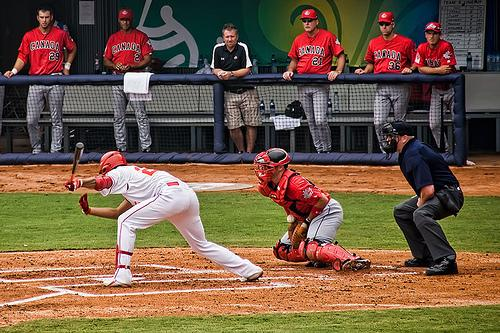What is the main object being used by the player in the image, and what is he doing with it? The main object used is a baseball bat, and the player is swinging it. Describe what the spectators in the image are doing. The spectators are watching the baseball game, with some standing and some sitting. Identify the sport being played in the image and the roles of the people involved in the game. The sport is baseball, and the people involved include players, a catcher, an umpire, and spectators. How many people are wearing baseball uniforms in the image? There are six people wearing baseball uniforms in the image. Can you identify an accessory worn by the man in the black shirt, and what is its color? The man in the black shirt is wearing a white towel. Describe the surface of the baseball field in the image. The surface of the baseball field consists of green grass and sand. Count the number of people's heads that are visible in the image. Four people's heads are visible in the image. What is the role of the person wearing a red mask in the baseball game? The person wearing a red mask is the catcher of the baseball game. What is the predominant color in the grass? The predominant color in the grass is green. Mention the color of the uniform worn by the baseball player, who is swinging the bat. The baseball player swinging the bat is wearing a white uniform. Is the catcher wearing a blue mask? The instruction refers to the catcher (X:250 Y:138 Width:120 Height:120) but it adds a misleading detail - a blue mask, which doesn't exist in the image. The catcher is wearing a red mask (X:251 Y:150 Width:103 Height:103). What type of game is being played in this image? Baseball What position is the baseball player in the image holding the bat taking? Swinging the bat Is there sand on the baseball field in this image? Yes, there is sand on the baseball field. What type of field is shown in the image? A baseball field with grass and sand areas. Describe the attire of the participants in the image. Participants are wearing baseball uniforms, caps, a red mask, and an all-black attire for the umpire. Is the umpire wearing a bright yellow shirt? The instruction refers to the umpire (X:376 Y:117 Width:90 Height:90), but it adds a misleading detail - a bright yellow shirt, which doesn't exist in the image. In this image with a baseball game, name an individual located near the players but not actively participating in the game. A coach Can you see a white towel in the image? If so, describe its position relative to other objects. Yes, it is located close to the people. In this baseball image, besides a player swinging a bat, does it include a catcher and an umpire? Yes, it includes a catcher and an umpire. Identify the character standing beside the catcher in the image. The umpire Is there a giant watermelon on the baseball field? There is no mention of any watermelon or anything related in the image. The instruction asks to identify something that doesn't exist in the image. Which apparel items are the baseball players wearing in this image? A) Baseball caps and uniforms B) Football helmets and pads C) Basketball jerseys and shorts A) Baseball caps and uniforms Can you find a person holding a green umbrella in the crowd? There is no mention of any umbrella, let alone a green one, in the image. The instruction asks to identify something that doesn't exist in the image. Which object is located closer to the center of the image - a person wearing a red mask or the umpire? A person wearing a red mask List the visible parts of a person in this image, such as head, arms, legs, or feet. Head, arms, legs, and feet Is the umpire wearing all black or all white? All black What is the activity taking place in the image? Watching a baseball game Which object is positioned below the man in the black shirt - a person's arm, a person's head, or a white towel? A white towel Can you see a player wearing a red baseball uniform? Several players are mentioned wearing baseball uniforms, but none of them are described as wearing a red baseball uniform. This instruction asks to identify something that doesn't exist in the image. Are there any dogs playing on the grass on the baseball field? There is no mention of dogs, only grass on the baseball field (X:6 Y:193 Width:480 Height:480). The instruction asks to identify something that doesn't exist in the image. Which of the following expressions are true about the image? A) People are watching a tennis match B) The baseball players are wearing uniforms C) The grass on the field is purple B) The baseball players are wearing uniforms Describe the scene taking place in the image. People are watching a baseball game with players wearing uniforms, a coach, and an umpire on the field. What are the spectators in the image doing? Watching the baseball game 